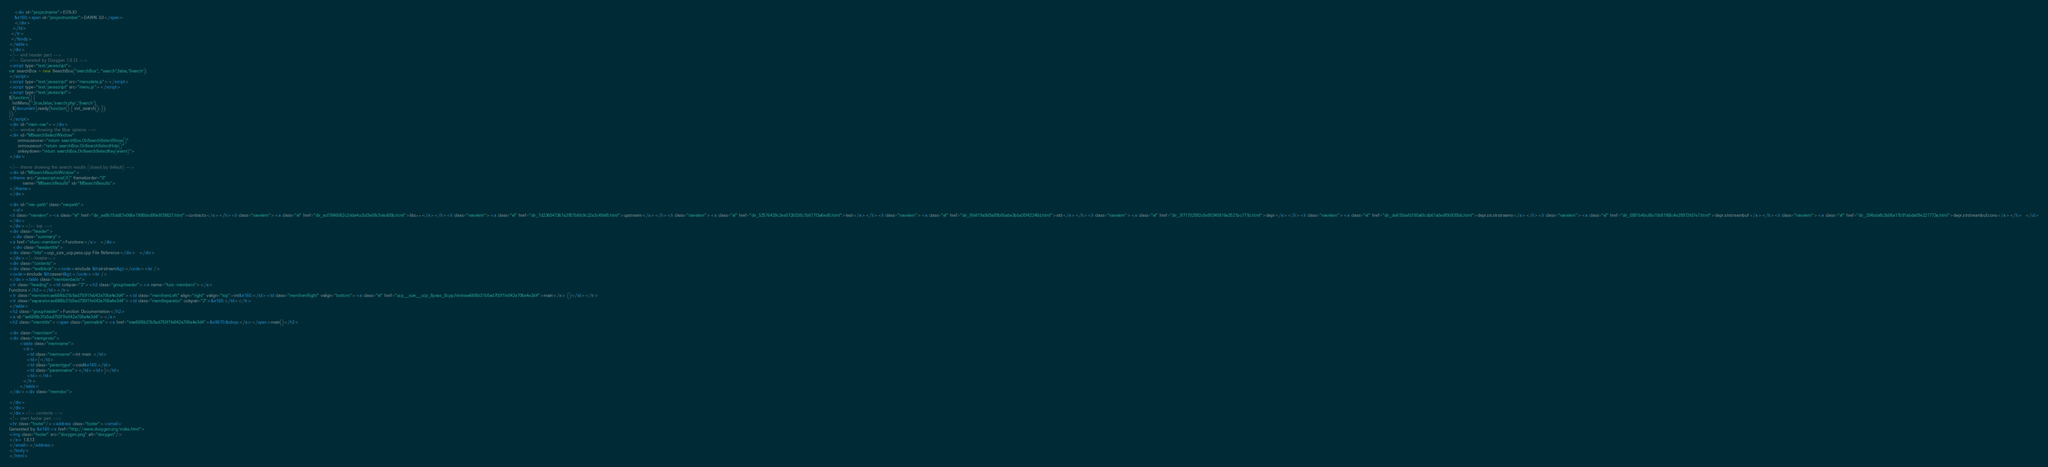<code> <loc_0><loc_0><loc_500><loc_500><_HTML_>   <div id="projectname">EOS.IO
   &#160;<span id="projectnumber">DAWN 3.0</span>
   </div>
  </td>
 </tr>
 </tbody>
</table>
</div>
<!-- end header part -->
<!-- Generated by Doxygen 1.8.13 -->
<script type="text/javascript">
var searchBox = new SearchBox("searchBox", "search",false,'Search');
</script>
<script type="text/javascript" src="menudata.js"></script>
<script type="text/javascript" src="menu.js"></script>
<script type="text/javascript">
$(function() {
  initMenu('',true,false,'search.php','Search');
  $(document).ready(function() { init_search(); });
});
</script>
<div id="main-nav"></div>
<!-- window showing the filter options -->
<div id="MSearchSelectWindow"
     onmouseover="return searchBox.OnSearchSelectShow()"
     onmouseout="return searchBox.OnSearchSelectHide()"
     onkeydown="return searchBox.OnSearchSelectKey(event)">
</div>

<!-- iframe showing the search results (closed by default) -->
<div id="MSearchResultsWindow">
<iframe src="javascript:void(0)" frameborder="0" 
        name="MSearchResults" id="MSearchResults">
</iframe>
</div>

<div id="nav-path" class="navpath">
  <ul>
<li class="navelem"><a class="el" href="dir_ae9b15dd87e066e1908bbd90e8f38627.html">contracts</a></li><li class="navelem"><a class="el" href="dir_acf7646062c2dda4cc5d3e08c5ded00b.html">libc++</a></li><li class="navelem"><a class="el" href="dir_7d236047367a2957b6fc9c22a3c49af8.html">upstream</a></li><li class="navelem"><a class="el" href="dir_52576429c2ea572b538c7b817f3a6ed0.html">test</a></li><li class="navelem"><a class="el" href="dir_8fe919a9d5a89b0babe3bba35f42248d.html">std</a></li><li class="navelem"><a class="el" href="dir_3f71702592c8a90340816a3521bc771b.html">depr</a></li><li class="navelem"><a class="el" href="dir_de615bafd180a6fcdb61a0edf0b935bb.html">depr.str.strstreams</a></li><li class="navelem"><a class="el" href="dir_0891b4bc6fa10b81f68c4e29972fd7e7.html">depr.strstreambuf</a></li><li class="navelem"><a class="el" href="dir_204bdafb2b06a17b91abda09e221773a.html">depr.strstreambuf.cons</a></li>  </ul>
</div>
</div><!-- top -->
<div class="header">
  <div class="summary">
<a href="#func-members">Functions</a>  </div>
  <div class="headertitle">
<div class="title">ucp_size_ucp.pass.cpp File Reference</div>  </div>
</div><!--header-->
<div class="contents">
<div class="textblock"><code>#include &lt;strstream&gt;</code><br />
<code>#include &lt;cassert&gt;</code><br />
</div><table class="memberdecls">
<tr class="heading"><td colspan="2"><h2 class="groupheader"><a name="func-members"></a>
Functions</h2></td></tr>
<tr class="memitem:ae66f6b31b5ad750f1fe042a706a4e3d4"><td class="memItemLeft" align="right" valign="top">int&#160;</td><td class="memItemRight" valign="bottom"><a class="el" href="ucp__size__ucp_8pass_8cpp.html#ae66f6b31b5ad750f1fe042a706a4e3d4">main</a> ()</td></tr>
<tr class="separator:ae66f6b31b5ad750f1fe042a706a4e3d4"><td class="memSeparator" colspan="2">&#160;</td></tr>
</table>
<h2 class="groupheader">Function Documentation</h2>
<a id="ae66f6b31b5ad750f1fe042a706a4e3d4"></a>
<h2 class="memtitle"><span class="permalink"><a href="#ae66f6b31b5ad750f1fe042a706a4e3d4">&#9670;&nbsp;</a></span>main()</h2>

<div class="memitem">
<div class="memproto">
      <table class="memname">
        <tr>
          <td class="memname">int main </td>
          <td>(</td>
          <td class="paramtype">void&#160;</td>
          <td class="paramname"></td><td>)</td>
          <td></td>
        </tr>
      </table>
</div><div class="memdoc">

</div>
</div>
</div><!-- contents -->
<!-- start footer part -->
<hr class="footer"/><address class="footer"><small>
Generated by &#160;<a href="http://www.doxygen.org/index.html">
<img class="footer" src="doxygen.png" alt="doxygen"/>
</a> 1.8.13
</small></address>
</body>
</html>
</code> 